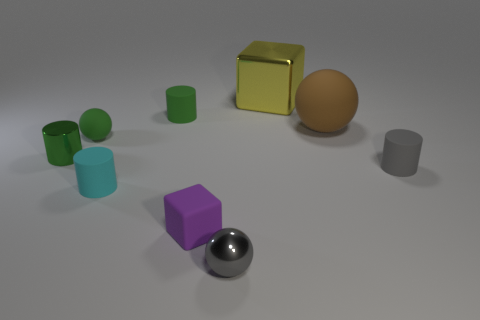Subtract all small rubber balls. How many balls are left? 2 Subtract all blocks. How many objects are left? 7 Subtract all green spheres. How many spheres are left? 2 Subtract 1 cubes. How many cubes are left? 1 Subtract all large brown spheres. Subtract all green matte cylinders. How many objects are left? 7 Add 6 tiny green rubber spheres. How many tiny green rubber spheres are left? 7 Add 4 large brown rubber objects. How many large brown rubber objects exist? 5 Subtract 0 gray cubes. How many objects are left? 9 Subtract all green cylinders. Subtract all cyan balls. How many cylinders are left? 2 Subtract all cyan spheres. How many gray cylinders are left? 1 